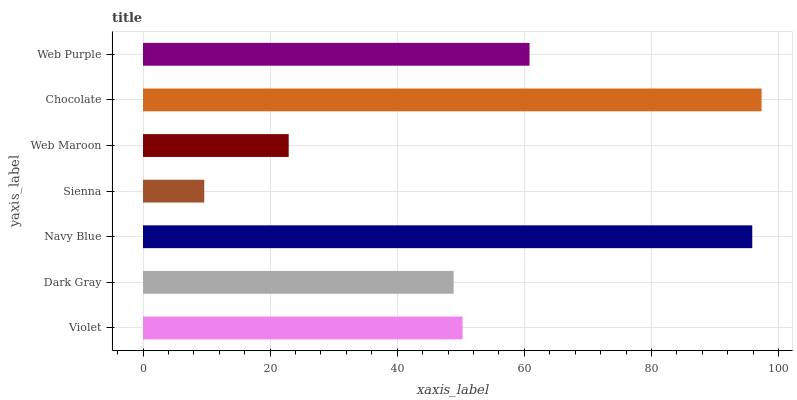Is Sienna the minimum?
Answer yes or no. Yes. Is Chocolate the maximum?
Answer yes or no. Yes. Is Dark Gray the minimum?
Answer yes or no. No. Is Dark Gray the maximum?
Answer yes or no. No. Is Violet greater than Dark Gray?
Answer yes or no. Yes. Is Dark Gray less than Violet?
Answer yes or no. Yes. Is Dark Gray greater than Violet?
Answer yes or no. No. Is Violet less than Dark Gray?
Answer yes or no. No. Is Violet the high median?
Answer yes or no. Yes. Is Violet the low median?
Answer yes or no. Yes. Is Sienna the high median?
Answer yes or no. No. Is Web Purple the low median?
Answer yes or no. No. 